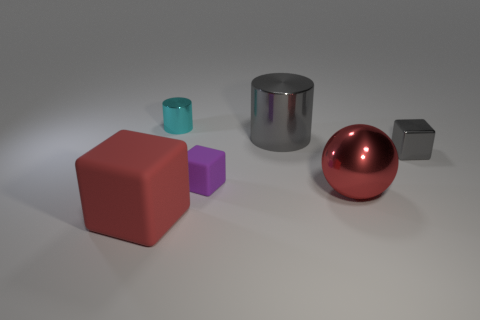Subtract all purple blocks. How many blocks are left? 2 Add 4 purple things. How many objects exist? 10 Subtract all red cubes. How many cubes are left? 2 Subtract all cylinders. How many objects are left? 4 Subtract 1 cylinders. How many cylinders are left? 1 Subtract 0 purple cylinders. How many objects are left? 6 Subtract all purple blocks. Subtract all blue cylinders. How many blocks are left? 2 Subtract all yellow cubes. How many gray cylinders are left? 1 Subtract all small gray shiny things. Subtract all large metal things. How many objects are left? 3 Add 6 matte cubes. How many matte cubes are left? 8 